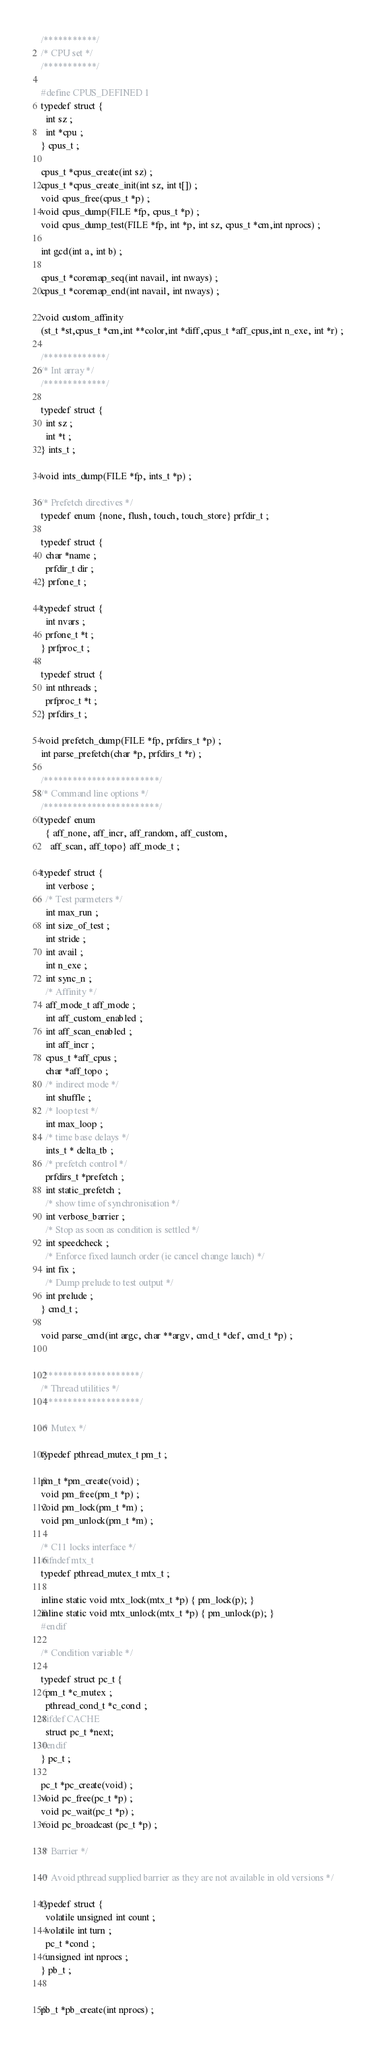Convert code to text. <code><loc_0><loc_0><loc_500><loc_500><_C_>/***********/
/* CPU set */
/***********/

#define CPUS_DEFINED 1
typedef struct {
  int sz ;
  int *cpu ;
} cpus_t ;

cpus_t *cpus_create(int sz) ;
cpus_t *cpus_create_init(int sz, int t[]) ;
void cpus_free(cpus_t *p) ;
void cpus_dump(FILE *fp, cpus_t *p) ;
void cpus_dump_test(FILE *fp, int *p, int sz, cpus_t *cm,int nprocs) ;

int gcd(int a, int b) ;

cpus_t *coremap_seq(int navail, int nways) ;
cpus_t *coremap_end(int navail, int nways) ;

void custom_affinity
(st_t *st,cpus_t *cm,int **color,int *diff,cpus_t *aff_cpus,int n_exe, int *r) ;

/*************/
/* Int array */
/*************/

typedef struct {
  int sz ;
  int *t ;
} ints_t ;

void ints_dump(FILE *fp, ints_t *p) ;

/* Prefetch directives */
typedef enum {none, flush, touch, touch_store} prfdir_t ;

typedef struct {
  char *name ;
  prfdir_t dir ;
} prfone_t ;

typedef struct {
  int nvars ;
  prfone_t *t ;
} prfproc_t ;

typedef struct {
  int nthreads ;
  prfproc_t *t ;
} prfdirs_t ;

void prefetch_dump(FILE *fp, prfdirs_t *p) ;
int parse_prefetch(char *p, prfdirs_t *r) ;

/************************/
/* Command line options */
/************************/
typedef enum
  { aff_none, aff_incr, aff_random, aff_custom,
    aff_scan, aff_topo} aff_mode_t ;

typedef struct {
  int verbose ;
  /* Test parmeters */
  int max_run ;
  int size_of_test ;
  int stride ;
  int avail ;
  int n_exe ;
  int sync_n ;
  /* Affinity */
  aff_mode_t aff_mode ;
  int aff_custom_enabled ;
  int aff_scan_enabled ;
  int aff_incr ;
  cpus_t *aff_cpus ;
  char *aff_topo ;
  /* indirect mode */
  int shuffle ;
  /* loop test */
  int max_loop ;
  /* time base delays */
  ints_t * delta_tb ;
  /* prefetch control */
  prfdirs_t *prefetch ;
  int static_prefetch ;
  /* show time of synchronisation */
  int verbose_barrier ;
  /* Stop as soon as condition is settled */
  int speedcheck ;
  /* Enforce fixed launch order (ie cancel change lauch) */
  int fix ;
  /* Dump prelude to test output */
  int prelude ;
} cmd_t ;

void parse_cmd(int argc, char **argv, cmd_t *def, cmd_t *p) ;


/********************/
/* Thread utilities */
/********************/

/* Mutex */

typedef pthread_mutex_t pm_t ;

pm_t *pm_create(void) ;
void pm_free(pm_t *p) ;
void pm_lock(pm_t *m) ;
void pm_unlock(pm_t *m) ;

/* C11 locks interface */
#ifndef mtx_t
typedef pthread_mutex_t mtx_t ;

inline static void mtx_lock(mtx_t *p) { pm_lock(p); }
inline static void mtx_unlock(mtx_t *p) { pm_unlock(p); }
#endif

/* Condition variable */

typedef struct pc_t {
  pm_t *c_mutex ;
  pthread_cond_t *c_cond ;
#ifdef CACHE
  struct pc_t *next;
#endif
} pc_t ;

pc_t *pc_create(void) ;
void pc_free(pc_t *p) ;
void pc_wait(pc_t *p) ;
void pc_broadcast (pc_t *p) ;

/* Barrier */

/* Avoid pthread supplied barrier as they are not available in old versions */

typedef struct {
  volatile unsigned int count ;
  volatile int turn ;
  pc_t *cond ;
  unsigned int nprocs ;
} pb_t ;


pb_t *pb_create(int nprocs) ;</code> 